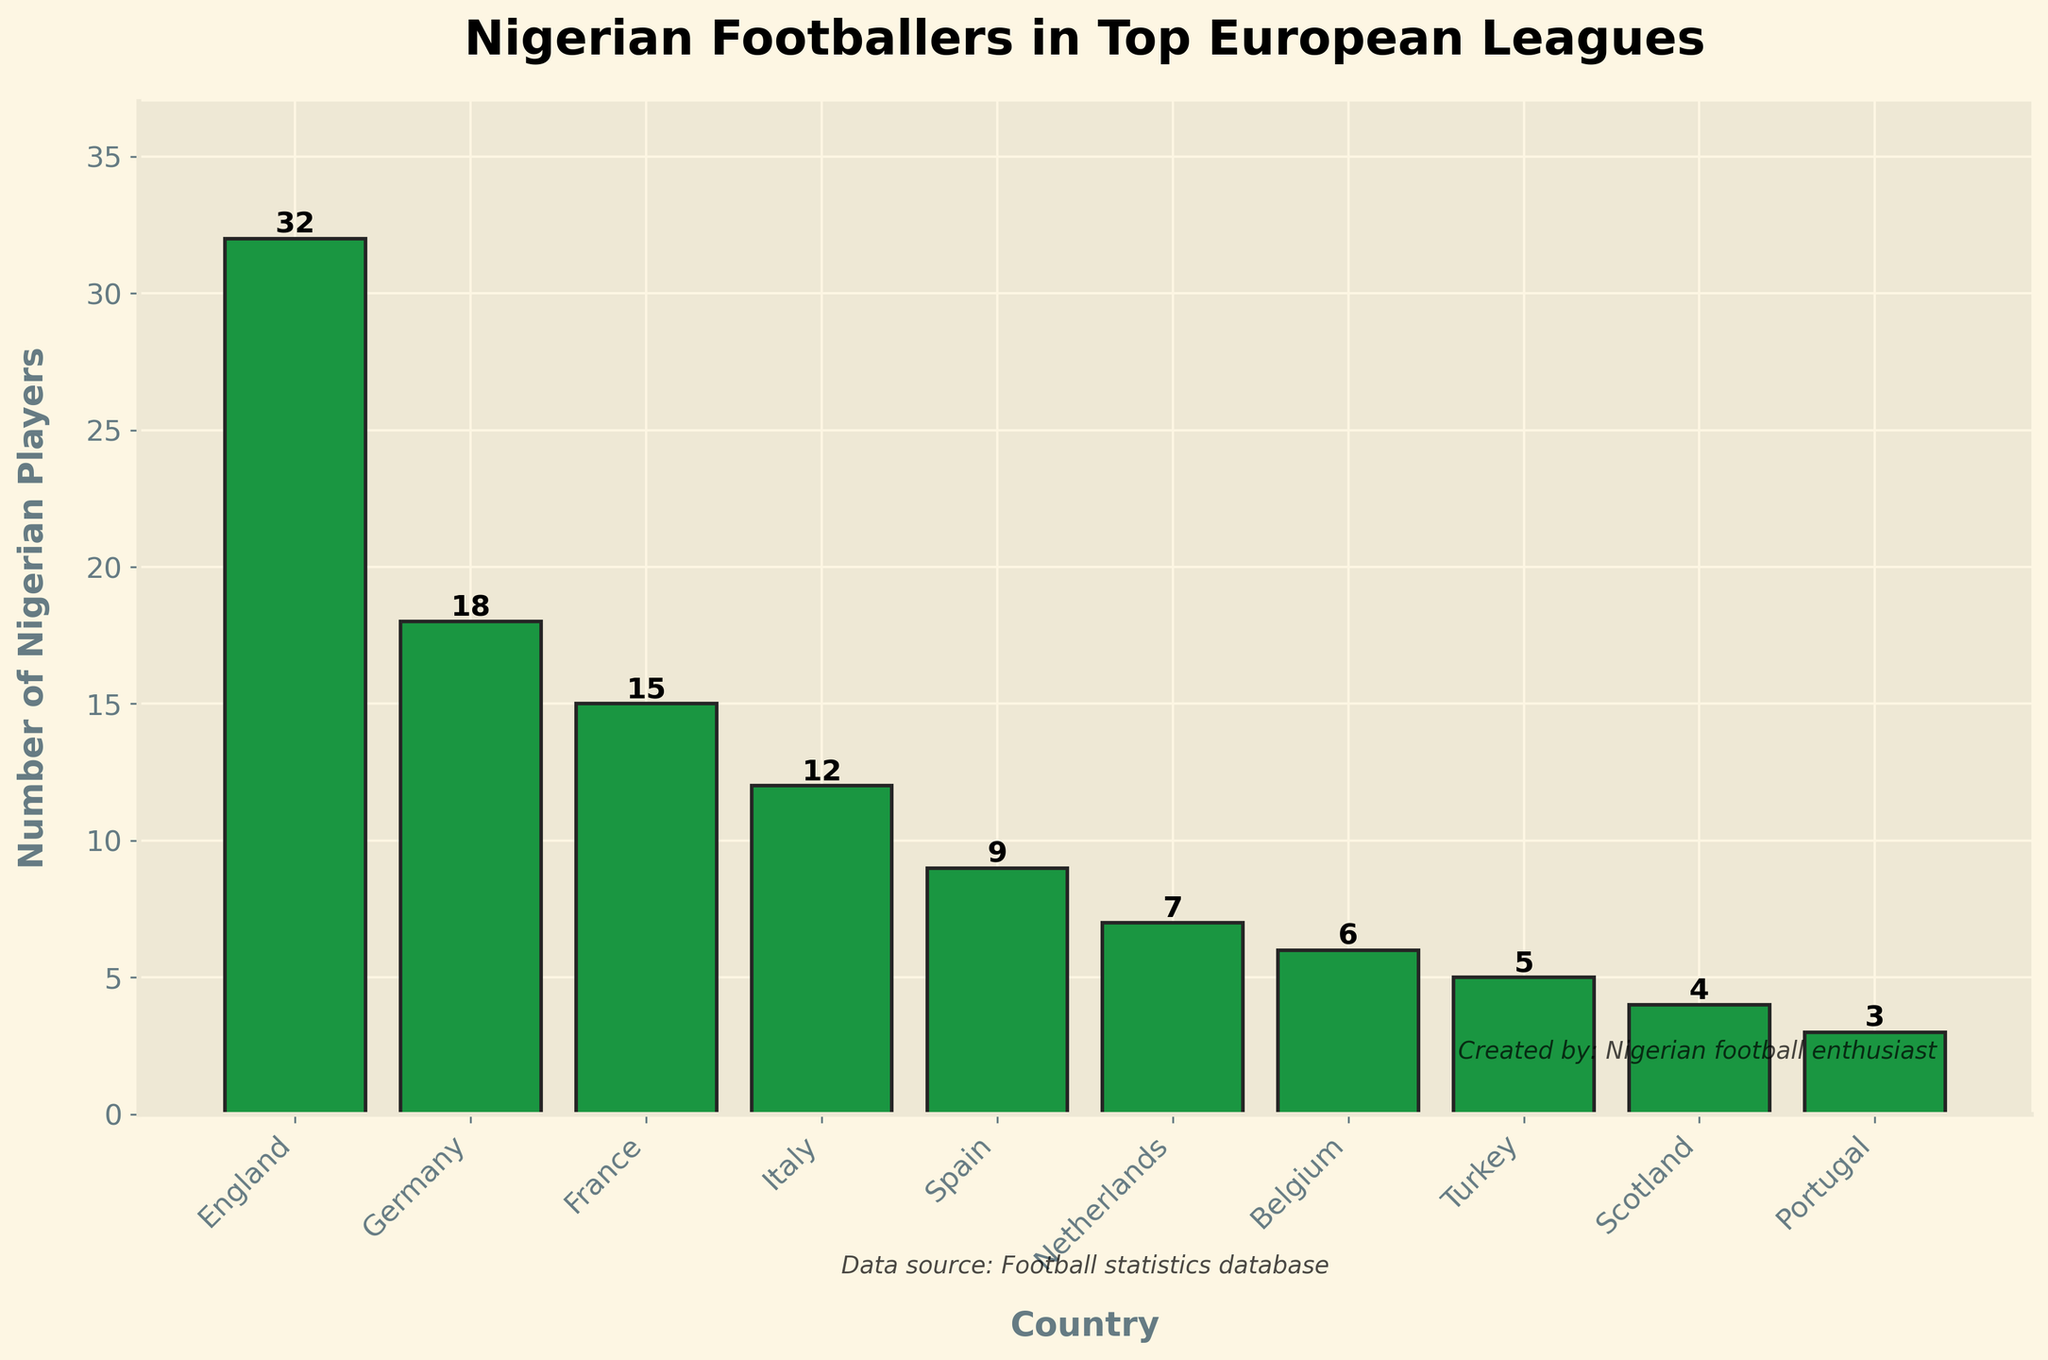How many Nigerian footballers are playing in the top European leagues overall? To find the total number of Nigerian footballers playing in the top European leagues, sum the number of players across all the countries listed: 32 (England) + 18 (Germany) + 15 (France) + 12 (Italy) + 9 (Spain) + 7 (Netherlands) + 6 (Belgium) + 5 (Turkey) + 4 (Scotland) + 3 (Portugal) = 111.
Answer: 111 Which country has the highest number of Nigerian footballers? From the bar chart, the tallest bar represents the country with the highest number of Nigerian footballers. England has the tallest bar with 32 players.
Answer: England How many more Nigerian footballers play in England compared to Spain? To find the difference in the number of Nigerian players between England and Spain: 32 (England) - 9 (Spain) = 23.
Answer: 23 What is the combined total of Nigerian footballers playing in Germany and France? Sum the number of Nigerian players in Germany and France: 18 (Germany) + 15 (France) = 33.
Answer: 33 Which country has the fewest number of Nigerian footballers? From the bar chart, the shortest bar represents the country with the fewest players. Portugal has the shortest bar with 3 players.
Answer: Portugal What percentage of the total number of Nigerian players are playing in Germany? First, find the total number of Nigerian players: 111. Then calculate the percentage of players in Germany: (18 / 111) * 100 = approximately 16.22%.
Answer: 16.22% Rank the countries by the number of Nigerian footballers from highest to lowest. The countries ranked by the number of Nigerian players in descending order are: England, Germany, France, Italy, Spain, Netherlands, Belgium, Turkey, Scotland, Portugal.
Answer: England, Germany, France, Italy, Spain, Netherlands, Belgium, Turkey, Scotland, Portugal What is the average number of Nigerian footballers per country in the chart? Sum the total number of Nigerian players, which is 111, and divide it by the number of countries, which is 10: 111 / 10 = 11.1.
Answer: 11.1 How many countries have more than 10 Nigerian footballers? From the bar chart, the countries that have more than 10 Nigerian players are England, Germany, France, and Italy. That's a total of 4 countries.
Answer: 4 Which countries have fewer Nigerian footballers than Belgium? Belgium has 6 Nigerian players. The countries with fewer players are Turkey, Scotland, and Portugal.
Answer: Turkey, Scotland, Portugal 